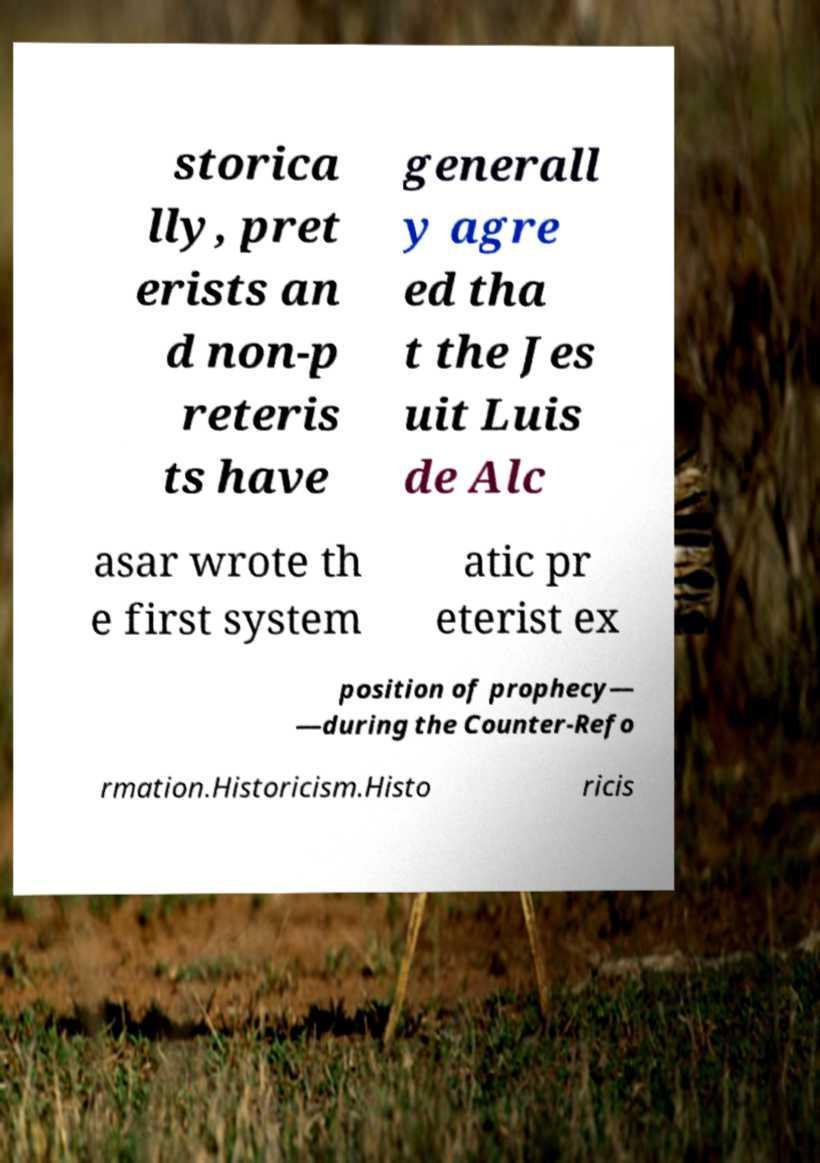For documentation purposes, I need the text within this image transcribed. Could you provide that? storica lly, pret erists an d non-p reteris ts have generall y agre ed tha t the Jes uit Luis de Alc asar wrote th e first system atic pr eterist ex position of prophecy— —during the Counter-Refo rmation.Historicism.Histo ricis 